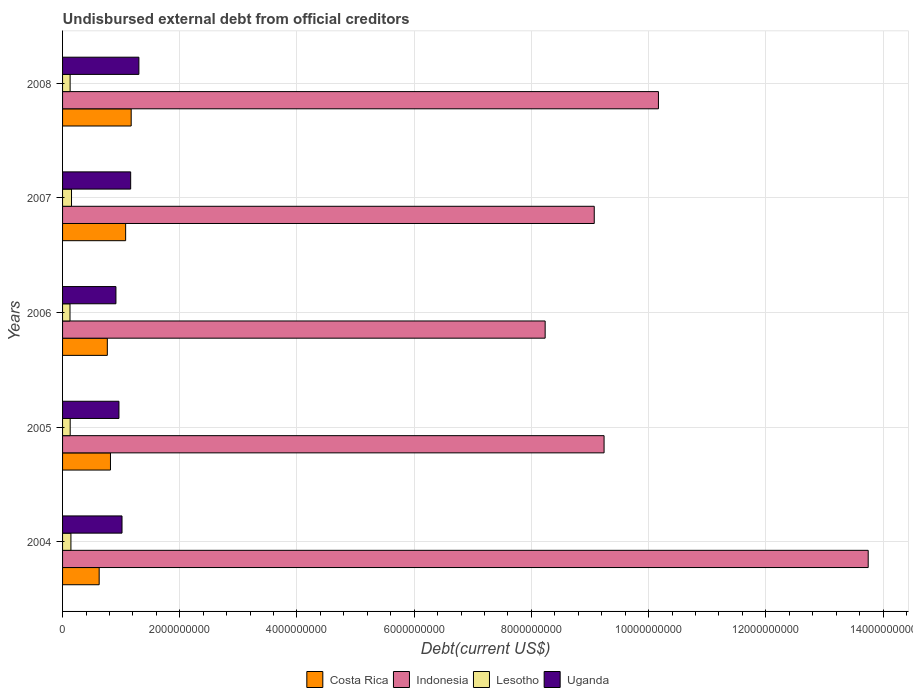How many bars are there on the 5th tick from the top?
Your answer should be very brief. 4. How many bars are there on the 4th tick from the bottom?
Offer a very short reply. 4. What is the total debt in Indonesia in 2005?
Ensure brevity in your answer.  9.24e+09. Across all years, what is the maximum total debt in Costa Rica?
Ensure brevity in your answer.  1.17e+09. Across all years, what is the minimum total debt in Lesotho?
Ensure brevity in your answer.  1.27e+08. In which year was the total debt in Costa Rica minimum?
Your answer should be compact. 2004. What is the total total debt in Uganda in the graph?
Your answer should be very brief. 5.35e+09. What is the difference between the total debt in Costa Rica in 2005 and that in 2006?
Keep it short and to the point. 5.35e+07. What is the difference between the total debt in Costa Rica in 2004 and the total debt in Indonesia in 2005?
Provide a succinct answer. -8.62e+09. What is the average total debt in Costa Rica per year?
Your answer should be very brief. 8.91e+08. In the year 2008, what is the difference between the total debt in Uganda and total debt in Indonesia?
Your answer should be very brief. -8.87e+09. What is the ratio of the total debt in Lesotho in 2004 to that in 2007?
Provide a short and direct response. 0.93. Is the total debt in Lesotho in 2007 less than that in 2008?
Provide a succinct answer. No. Is the difference between the total debt in Uganda in 2004 and 2007 greater than the difference between the total debt in Indonesia in 2004 and 2007?
Make the answer very short. No. What is the difference between the highest and the second highest total debt in Lesotho?
Your response must be concise. 1.01e+07. What is the difference between the highest and the lowest total debt in Costa Rica?
Provide a succinct answer. 5.46e+08. Is it the case that in every year, the sum of the total debt in Costa Rica and total debt in Lesotho is greater than the sum of total debt in Indonesia and total debt in Uganda?
Offer a very short reply. No. What does the 1st bar from the top in 2006 represents?
Provide a succinct answer. Uganda. What does the 2nd bar from the bottom in 2008 represents?
Your answer should be very brief. Indonesia. Are all the bars in the graph horizontal?
Your answer should be compact. Yes. Are the values on the major ticks of X-axis written in scientific E-notation?
Your answer should be very brief. No. Does the graph contain any zero values?
Give a very brief answer. No. Where does the legend appear in the graph?
Keep it short and to the point. Bottom center. How many legend labels are there?
Provide a short and direct response. 4. How are the legend labels stacked?
Give a very brief answer. Horizontal. What is the title of the graph?
Offer a very short reply. Undisbursed external debt from official creditors. Does "Eritrea" appear as one of the legend labels in the graph?
Your answer should be very brief. No. What is the label or title of the X-axis?
Keep it short and to the point. Debt(current US$). What is the label or title of the Y-axis?
Make the answer very short. Years. What is the Debt(current US$) in Costa Rica in 2004?
Your response must be concise. 6.25e+08. What is the Debt(current US$) in Indonesia in 2004?
Make the answer very short. 1.37e+1. What is the Debt(current US$) of Lesotho in 2004?
Your response must be concise. 1.43e+08. What is the Debt(current US$) of Uganda in 2004?
Ensure brevity in your answer.  1.01e+09. What is the Debt(current US$) in Costa Rica in 2005?
Provide a succinct answer. 8.17e+08. What is the Debt(current US$) in Indonesia in 2005?
Your answer should be very brief. 9.24e+09. What is the Debt(current US$) in Lesotho in 2005?
Keep it short and to the point. 1.30e+08. What is the Debt(current US$) in Uganda in 2005?
Your response must be concise. 9.62e+08. What is the Debt(current US$) of Costa Rica in 2006?
Offer a terse response. 7.64e+08. What is the Debt(current US$) of Indonesia in 2006?
Provide a short and direct response. 8.23e+09. What is the Debt(current US$) in Lesotho in 2006?
Make the answer very short. 1.27e+08. What is the Debt(current US$) of Uganda in 2006?
Provide a succinct answer. 9.11e+08. What is the Debt(current US$) in Costa Rica in 2007?
Offer a very short reply. 1.08e+09. What is the Debt(current US$) of Indonesia in 2007?
Offer a terse response. 9.07e+09. What is the Debt(current US$) of Lesotho in 2007?
Provide a short and direct response. 1.53e+08. What is the Debt(current US$) of Uganda in 2007?
Provide a short and direct response. 1.16e+09. What is the Debt(current US$) in Costa Rica in 2008?
Offer a very short reply. 1.17e+09. What is the Debt(current US$) of Indonesia in 2008?
Ensure brevity in your answer.  1.02e+1. What is the Debt(current US$) of Lesotho in 2008?
Offer a very short reply. 1.29e+08. What is the Debt(current US$) of Uganda in 2008?
Your response must be concise. 1.30e+09. Across all years, what is the maximum Debt(current US$) in Costa Rica?
Offer a terse response. 1.17e+09. Across all years, what is the maximum Debt(current US$) of Indonesia?
Offer a terse response. 1.37e+1. Across all years, what is the maximum Debt(current US$) in Lesotho?
Make the answer very short. 1.53e+08. Across all years, what is the maximum Debt(current US$) in Uganda?
Offer a very short reply. 1.30e+09. Across all years, what is the minimum Debt(current US$) in Costa Rica?
Offer a terse response. 6.25e+08. Across all years, what is the minimum Debt(current US$) in Indonesia?
Offer a terse response. 8.23e+09. Across all years, what is the minimum Debt(current US$) of Lesotho?
Your answer should be compact. 1.27e+08. Across all years, what is the minimum Debt(current US$) in Uganda?
Offer a terse response. 9.11e+08. What is the total Debt(current US$) of Costa Rica in the graph?
Make the answer very short. 4.45e+09. What is the total Debt(current US$) of Indonesia in the graph?
Provide a succinct answer. 5.05e+1. What is the total Debt(current US$) in Lesotho in the graph?
Your response must be concise. 6.81e+08. What is the total Debt(current US$) of Uganda in the graph?
Give a very brief answer. 5.35e+09. What is the difference between the Debt(current US$) of Costa Rica in 2004 and that in 2005?
Offer a very short reply. -1.93e+08. What is the difference between the Debt(current US$) in Indonesia in 2004 and that in 2005?
Your answer should be very brief. 4.51e+09. What is the difference between the Debt(current US$) in Lesotho in 2004 and that in 2005?
Your answer should be compact. 1.26e+07. What is the difference between the Debt(current US$) of Uganda in 2004 and that in 2005?
Offer a very short reply. 5.22e+07. What is the difference between the Debt(current US$) in Costa Rica in 2004 and that in 2006?
Keep it short and to the point. -1.39e+08. What is the difference between the Debt(current US$) in Indonesia in 2004 and that in 2006?
Your answer should be compact. 5.51e+09. What is the difference between the Debt(current US$) in Lesotho in 2004 and that in 2006?
Keep it short and to the point. 1.57e+07. What is the difference between the Debt(current US$) of Uganda in 2004 and that in 2006?
Provide a short and direct response. 1.04e+08. What is the difference between the Debt(current US$) of Costa Rica in 2004 and that in 2007?
Your response must be concise. -4.52e+08. What is the difference between the Debt(current US$) in Indonesia in 2004 and that in 2007?
Your response must be concise. 4.67e+09. What is the difference between the Debt(current US$) in Lesotho in 2004 and that in 2007?
Offer a terse response. -1.01e+07. What is the difference between the Debt(current US$) of Uganda in 2004 and that in 2007?
Give a very brief answer. -1.48e+08. What is the difference between the Debt(current US$) in Costa Rica in 2004 and that in 2008?
Your answer should be compact. -5.46e+08. What is the difference between the Debt(current US$) in Indonesia in 2004 and that in 2008?
Your answer should be very brief. 3.58e+09. What is the difference between the Debt(current US$) of Lesotho in 2004 and that in 2008?
Ensure brevity in your answer.  1.35e+07. What is the difference between the Debt(current US$) of Uganda in 2004 and that in 2008?
Make the answer very short. -2.88e+08. What is the difference between the Debt(current US$) in Costa Rica in 2005 and that in 2006?
Make the answer very short. 5.35e+07. What is the difference between the Debt(current US$) in Indonesia in 2005 and that in 2006?
Keep it short and to the point. 1.01e+09. What is the difference between the Debt(current US$) in Lesotho in 2005 and that in 2006?
Ensure brevity in your answer.  3.10e+06. What is the difference between the Debt(current US$) in Uganda in 2005 and that in 2006?
Make the answer very short. 5.15e+07. What is the difference between the Debt(current US$) of Costa Rica in 2005 and that in 2007?
Provide a succinct answer. -2.59e+08. What is the difference between the Debt(current US$) in Indonesia in 2005 and that in 2007?
Give a very brief answer. 1.68e+08. What is the difference between the Debt(current US$) in Lesotho in 2005 and that in 2007?
Offer a very short reply. -2.27e+07. What is the difference between the Debt(current US$) in Uganda in 2005 and that in 2007?
Keep it short and to the point. -2.00e+08. What is the difference between the Debt(current US$) of Costa Rica in 2005 and that in 2008?
Provide a succinct answer. -3.53e+08. What is the difference between the Debt(current US$) of Indonesia in 2005 and that in 2008?
Your answer should be very brief. -9.28e+08. What is the difference between the Debt(current US$) in Lesotho in 2005 and that in 2008?
Offer a very short reply. 8.88e+05. What is the difference between the Debt(current US$) of Uganda in 2005 and that in 2008?
Your response must be concise. -3.40e+08. What is the difference between the Debt(current US$) of Costa Rica in 2006 and that in 2007?
Your response must be concise. -3.12e+08. What is the difference between the Debt(current US$) of Indonesia in 2006 and that in 2007?
Provide a succinct answer. -8.38e+08. What is the difference between the Debt(current US$) in Lesotho in 2006 and that in 2007?
Offer a terse response. -2.58e+07. What is the difference between the Debt(current US$) in Uganda in 2006 and that in 2007?
Your response must be concise. -2.51e+08. What is the difference between the Debt(current US$) in Costa Rica in 2006 and that in 2008?
Your answer should be compact. -4.07e+08. What is the difference between the Debt(current US$) in Indonesia in 2006 and that in 2008?
Your answer should be compact. -1.93e+09. What is the difference between the Debt(current US$) of Lesotho in 2006 and that in 2008?
Ensure brevity in your answer.  -2.21e+06. What is the difference between the Debt(current US$) in Uganda in 2006 and that in 2008?
Offer a very short reply. -3.92e+08. What is the difference between the Debt(current US$) of Costa Rica in 2007 and that in 2008?
Your response must be concise. -9.47e+07. What is the difference between the Debt(current US$) of Indonesia in 2007 and that in 2008?
Your response must be concise. -1.10e+09. What is the difference between the Debt(current US$) in Lesotho in 2007 and that in 2008?
Your answer should be compact. 2.36e+07. What is the difference between the Debt(current US$) of Uganda in 2007 and that in 2008?
Offer a terse response. -1.40e+08. What is the difference between the Debt(current US$) of Costa Rica in 2004 and the Debt(current US$) of Indonesia in 2005?
Provide a succinct answer. -8.62e+09. What is the difference between the Debt(current US$) of Costa Rica in 2004 and the Debt(current US$) of Lesotho in 2005?
Your answer should be compact. 4.95e+08. What is the difference between the Debt(current US$) of Costa Rica in 2004 and the Debt(current US$) of Uganda in 2005?
Your response must be concise. -3.38e+08. What is the difference between the Debt(current US$) in Indonesia in 2004 and the Debt(current US$) in Lesotho in 2005?
Your response must be concise. 1.36e+1. What is the difference between the Debt(current US$) in Indonesia in 2004 and the Debt(current US$) in Uganda in 2005?
Your response must be concise. 1.28e+1. What is the difference between the Debt(current US$) of Lesotho in 2004 and the Debt(current US$) of Uganda in 2005?
Provide a succinct answer. -8.20e+08. What is the difference between the Debt(current US$) of Costa Rica in 2004 and the Debt(current US$) of Indonesia in 2006?
Offer a very short reply. -7.61e+09. What is the difference between the Debt(current US$) in Costa Rica in 2004 and the Debt(current US$) in Lesotho in 2006?
Make the answer very short. 4.98e+08. What is the difference between the Debt(current US$) in Costa Rica in 2004 and the Debt(current US$) in Uganda in 2006?
Offer a terse response. -2.86e+08. What is the difference between the Debt(current US$) in Indonesia in 2004 and the Debt(current US$) in Lesotho in 2006?
Provide a short and direct response. 1.36e+1. What is the difference between the Debt(current US$) in Indonesia in 2004 and the Debt(current US$) in Uganda in 2006?
Ensure brevity in your answer.  1.28e+1. What is the difference between the Debt(current US$) in Lesotho in 2004 and the Debt(current US$) in Uganda in 2006?
Provide a short and direct response. -7.68e+08. What is the difference between the Debt(current US$) of Costa Rica in 2004 and the Debt(current US$) of Indonesia in 2007?
Keep it short and to the point. -8.45e+09. What is the difference between the Debt(current US$) in Costa Rica in 2004 and the Debt(current US$) in Lesotho in 2007?
Your answer should be compact. 4.72e+08. What is the difference between the Debt(current US$) in Costa Rica in 2004 and the Debt(current US$) in Uganda in 2007?
Make the answer very short. -5.38e+08. What is the difference between the Debt(current US$) in Indonesia in 2004 and the Debt(current US$) in Lesotho in 2007?
Your response must be concise. 1.36e+1. What is the difference between the Debt(current US$) of Indonesia in 2004 and the Debt(current US$) of Uganda in 2007?
Provide a short and direct response. 1.26e+1. What is the difference between the Debt(current US$) of Lesotho in 2004 and the Debt(current US$) of Uganda in 2007?
Offer a very short reply. -1.02e+09. What is the difference between the Debt(current US$) in Costa Rica in 2004 and the Debt(current US$) in Indonesia in 2008?
Your answer should be compact. -9.54e+09. What is the difference between the Debt(current US$) in Costa Rica in 2004 and the Debt(current US$) in Lesotho in 2008?
Your answer should be compact. 4.95e+08. What is the difference between the Debt(current US$) of Costa Rica in 2004 and the Debt(current US$) of Uganda in 2008?
Provide a short and direct response. -6.78e+08. What is the difference between the Debt(current US$) of Indonesia in 2004 and the Debt(current US$) of Lesotho in 2008?
Your answer should be very brief. 1.36e+1. What is the difference between the Debt(current US$) of Indonesia in 2004 and the Debt(current US$) of Uganda in 2008?
Offer a terse response. 1.24e+1. What is the difference between the Debt(current US$) of Lesotho in 2004 and the Debt(current US$) of Uganda in 2008?
Provide a short and direct response. -1.16e+09. What is the difference between the Debt(current US$) in Costa Rica in 2005 and the Debt(current US$) in Indonesia in 2006?
Your response must be concise. -7.42e+09. What is the difference between the Debt(current US$) in Costa Rica in 2005 and the Debt(current US$) in Lesotho in 2006?
Your answer should be compact. 6.90e+08. What is the difference between the Debt(current US$) of Costa Rica in 2005 and the Debt(current US$) of Uganda in 2006?
Ensure brevity in your answer.  -9.34e+07. What is the difference between the Debt(current US$) of Indonesia in 2005 and the Debt(current US$) of Lesotho in 2006?
Offer a very short reply. 9.11e+09. What is the difference between the Debt(current US$) in Indonesia in 2005 and the Debt(current US$) in Uganda in 2006?
Your answer should be very brief. 8.33e+09. What is the difference between the Debt(current US$) in Lesotho in 2005 and the Debt(current US$) in Uganda in 2006?
Offer a terse response. -7.81e+08. What is the difference between the Debt(current US$) of Costa Rica in 2005 and the Debt(current US$) of Indonesia in 2007?
Your answer should be compact. -8.25e+09. What is the difference between the Debt(current US$) of Costa Rica in 2005 and the Debt(current US$) of Lesotho in 2007?
Provide a short and direct response. 6.65e+08. What is the difference between the Debt(current US$) of Costa Rica in 2005 and the Debt(current US$) of Uganda in 2007?
Provide a succinct answer. -3.45e+08. What is the difference between the Debt(current US$) in Indonesia in 2005 and the Debt(current US$) in Lesotho in 2007?
Your answer should be compact. 9.09e+09. What is the difference between the Debt(current US$) of Indonesia in 2005 and the Debt(current US$) of Uganda in 2007?
Make the answer very short. 8.08e+09. What is the difference between the Debt(current US$) of Lesotho in 2005 and the Debt(current US$) of Uganda in 2007?
Your response must be concise. -1.03e+09. What is the difference between the Debt(current US$) in Costa Rica in 2005 and the Debt(current US$) in Indonesia in 2008?
Your answer should be very brief. -9.35e+09. What is the difference between the Debt(current US$) of Costa Rica in 2005 and the Debt(current US$) of Lesotho in 2008?
Provide a succinct answer. 6.88e+08. What is the difference between the Debt(current US$) of Costa Rica in 2005 and the Debt(current US$) of Uganda in 2008?
Make the answer very short. -4.85e+08. What is the difference between the Debt(current US$) of Indonesia in 2005 and the Debt(current US$) of Lesotho in 2008?
Ensure brevity in your answer.  9.11e+09. What is the difference between the Debt(current US$) of Indonesia in 2005 and the Debt(current US$) of Uganda in 2008?
Your answer should be very brief. 7.94e+09. What is the difference between the Debt(current US$) in Lesotho in 2005 and the Debt(current US$) in Uganda in 2008?
Offer a very short reply. -1.17e+09. What is the difference between the Debt(current US$) of Costa Rica in 2006 and the Debt(current US$) of Indonesia in 2007?
Offer a terse response. -8.31e+09. What is the difference between the Debt(current US$) of Costa Rica in 2006 and the Debt(current US$) of Lesotho in 2007?
Offer a very short reply. 6.11e+08. What is the difference between the Debt(current US$) of Costa Rica in 2006 and the Debt(current US$) of Uganda in 2007?
Offer a very short reply. -3.98e+08. What is the difference between the Debt(current US$) of Indonesia in 2006 and the Debt(current US$) of Lesotho in 2007?
Your response must be concise. 8.08e+09. What is the difference between the Debt(current US$) of Indonesia in 2006 and the Debt(current US$) of Uganda in 2007?
Your response must be concise. 7.07e+09. What is the difference between the Debt(current US$) of Lesotho in 2006 and the Debt(current US$) of Uganda in 2007?
Your answer should be compact. -1.04e+09. What is the difference between the Debt(current US$) of Costa Rica in 2006 and the Debt(current US$) of Indonesia in 2008?
Provide a succinct answer. -9.40e+09. What is the difference between the Debt(current US$) in Costa Rica in 2006 and the Debt(current US$) in Lesotho in 2008?
Give a very brief answer. 6.35e+08. What is the difference between the Debt(current US$) in Costa Rica in 2006 and the Debt(current US$) in Uganda in 2008?
Provide a succinct answer. -5.38e+08. What is the difference between the Debt(current US$) of Indonesia in 2006 and the Debt(current US$) of Lesotho in 2008?
Your response must be concise. 8.11e+09. What is the difference between the Debt(current US$) of Indonesia in 2006 and the Debt(current US$) of Uganda in 2008?
Give a very brief answer. 6.93e+09. What is the difference between the Debt(current US$) in Lesotho in 2006 and the Debt(current US$) in Uganda in 2008?
Provide a short and direct response. -1.18e+09. What is the difference between the Debt(current US$) in Costa Rica in 2007 and the Debt(current US$) in Indonesia in 2008?
Your answer should be compact. -9.09e+09. What is the difference between the Debt(current US$) of Costa Rica in 2007 and the Debt(current US$) of Lesotho in 2008?
Provide a succinct answer. 9.47e+08. What is the difference between the Debt(current US$) in Costa Rica in 2007 and the Debt(current US$) in Uganda in 2008?
Provide a short and direct response. -2.26e+08. What is the difference between the Debt(current US$) in Indonesia in 2007 and the Debt(current US$) in Lesotho in 2008?
Your answer should be compact. 8.94e+09. What is the difference between the Debt(current US$) of Indonesia in 2007 and the Debt(current US$) of Uganda in 2008?
Give a very brief answer. 7.77e+09. What is the difference between the Debt(current US$) in Lesotho in 2007 and the Debt(current US$) in Uganda in 2008?
Your answer should be compact. -1.15e+09. What is the average Debt(current US$) in Costa Rica per year?
Provide a succinct answer. 8.91e+08. What is the average Debt(current US$) in Indonesia per year?
Offer a terse response. 1.01e+1. What is the average Debt(current US$) of Lesotho per year?
Offer a very short reply. 1.36e+08. What is the average Debt(current US$) of Uganda per year?
Make the answer very short. 1.07e+09. In the year 2004, what is the difference between the Debt(current US$) in Costa Rica and Debt(current US$) in Indonesia?
Provide a succinct answer. -1.31e+1. In the year 2004, what is the difference between the Debt(current US$) of Costa Rica and Debt(current US$) of Lesotho?
Offer a terse response. 4.82e+08. In the year 2004, what is the difference between the Debt(current US$) in Costa Rica and Debt(current US$) in Uganda?
Provide a short and direct response. -3.90e+08. In the year 2004, what is the difference between the Debt(current US$) of Indonesia and Debt(current US$) of Lesotho?
Offer a terse response. 1.36e+1. In the year 2004, what is the difference between the Debt(current US$) of Indonesia and Debt(current US$) of Uganda?
Keep it short and to the point. 1.27e+1. In the year 2004, what is the difference between the Debt(current US$) of Lesotho and Debt(current US$) of Uganda?
Make the answer very short. -8.72e+08. In the year 2005, what is the difference between the Debt(current US$) of Costa Rica and Debt(current US$) of Indonesia?
Make the answer very short. -8.42e+09. In the year 2005, what is the difference between the Debt(current US$) of Costa Rica and Debt(current US$) of Lesotho?
Offer a terse response. 6.87e+08. In the year 2005, what is the difference between the Debt(current US$) in Costa Rica and Debt(current US$) in Uganda?
Give a very brief answer. -1.45e+08. In the year 2005, what is the difference between the Debt(current US$) in Indonesia and Debt(current US$) in Lesotho?
Your answer should be very brief. 9.11e+09. In the year 2005, what is the difference between the Debt(current US$) in Indonesia and Debt(current US$) in Uganda?
Your answer should be very brief. 8.28e+09. In the year 2005, what is the difference between the Debt(current US$) in Lesotho and Debt(current US$) in Uganda?
Give a very brief answer. -8.32e+08. In the year 2006, what is the difference between the Debt(current US$) of Costa Rica and Debt(current US$) of Indonesia?
Your answer should be very brief. -7.47e+09. In the year 2006, what is the difference between the Debt(current US$) in Costa Rica and Debt(current US$) in Lesotho?
Your response must be concise. 6.37e+08. In the year 2006, what is the difference between the Debt(current US$) in Costa Rica and Debt(current US$) in Uganda?
Offer a terse response. -1.47e+08. In the year 2006, what is the difference between the Debt(current US$) in Indonesia and Debt(current US$) in Lesotho?
Provide a short and direct response. 8.11e+09. In the year 2006, what is the difference between the Debt(current US$) of Indonesia and Debt(current US$) of Uganda?
Your answer should be very brief. 7.32e+09. In the year 2006, what is the difference between the Debt(current US$) of Lesotho and Debt(current US$) of Uganda?
Offer a very short reply. -7.84e+08. In the year 2007, what is the difference between the Debt(current US$) in Costa Rica and Debt(current US$) in Indonesia?
Ensure brevity in your answer.  -8.00e+09. In the year 2007, what is the difference between the Debt(current US$) of Costa Rica and Debt(current US$) of Lesotho?
Make the answer very short. 9.23e+08. In the year 2007, what is the difference between the Debt(current US$) of Costa Rica and Debt(current US$) of Uganda?
Your answer should be compact. -8.60e+07. In the year 2007, what is the difference between the Debt(current US$) of Indonesia and Debt(current US$) of Lesotho?
Offer a very short reply. 8.92e+09. In the year 2007, what is the difference between the Debt(current US$) of Indonesia and Debt(current US$) of Uganda?
Offer a terse response. 7.91e+09. In the year 2007, what is the difference between the Debt(current US$) of Lesotho and Debt(current US$) of Uganda?
Offer a very short reply. -1.01e+09. In the year 2008, what is the difference between the Debt(current US$) in Costa Rica and Debt(current US$) in Indonesia?
Your response must be concise. -9.00e+09. In the year 2008, what is the difference between the Debt(current US$) of Costa Rica and Debt(current US$) of Lesotho?
Ensure brevity in your answer.  1.04e+09. In the year 2008, what is the difference between the Debt(current US$) of Costa Rica and Debt(current US$) of Uganda?
Provide a short and direct response. -1.31e+08. In the year 2008, what is the difference between the Debt(current US$) of Indonesia and Debt(current US$) of Lesotho?
Offer a very short reply. 1.00e+1. In the year 2008, what is the difference between the Debt(current US$) of Indonesia and Debt(current US$) of Uganda?
Make the answer very short. 8.87e+09. In the year 2008, what is the difference between the Debt(current US$) in Lesotho and Debt(current US$) in Uganda?
Your answer should be compact. -1.17e+09. What is the ratio of the Debt(current US$) of Costa Rica in 2004 to that in 2005?
Offer a very short reply. 0.76. What is the ratio of the Debt(current US$) of Indonesia in 2004 to that in 2005?
Offer a very short reply. 1.49. What is the ratio of the Debt(current US$) in Lesotho in 2004 to that in 2005?
Provide a short and direct response. 1.1. What is the ratio of the Debt(current US$) in Uganda in 2004 to that in 2005?
Your answer should be compact. 1.05. What is the ratio of the Debt(current US$) in Costa Rica in 2004 to that in 2006?
Give a very brief answer. 0.82. What is the ratio of the Debt(current US$) in Indonesia in 2004 to that in 2006?
Ensure brevity in your answer.  1.67. What is the ratio of the Debt(current US$) in Lesotho in 2004 to that in 2006?
Make the answer very short. 1.12. What is the ratio of the Debt(current US$) of Uganda in 2004 to that in 2006?
Provide a succinct answer. 1.11. What is the ratio of the Debt(current US$) of Costa Rica in 2004 to that in 2007?
Give a very brief answer. 0.58. What is the ratio of the Debt(current US$) of Indonesia in 2004 to that in 2007?
Your answer should be compact. 1.52. What is the ratio of the Debt(current US$) in Lesotho in 2004 to that in 2007?
Your response must be concise. 0.93. What is the ratio of the Debt(current US$) in Uganda in 2004 to that in 2007?
Make the answer very short. 0.87. What is the ratio of the Debt(current US$) in Costa Rica in 2004 to that in 2008?
Give a very brief answer. 0.53. What is the ratio of the Debt(current US$) in Indonesia in 2004 to that in 2008?
Keep it short and to the point. 1.35. What is the ratio of the Debt(current US$) in Lesotho in 2004 to that in 2008?
Keep it short and to the point. 1.1. What is the ratio of the Debt(current US$) of Uganda in 2004 to that in 2008?
Offer a very short reply. 0.78. What is the ratio of the Debt(current US$) in Costa Rica in 2005 to that in 2006?
Provide a short and direct response. 1.07. What is the ratio of the Debt(current US$) in Indonesia in 2005 to that in 2006?
Give a very brief answer. 1.12. What is the ratio of the Debt(current US$) in Lesotho in 2005 to that in 2006?
Make the answer very short. 1.02. What is the ratio of the Debt(current US$) in Uganda in 2005 to that in 2006?
Keep it short and to the point. 1.06. What is the ratio of the Debt(current US$) in Costa Rica in 2005 to that in 2007?
Provide a short and direct response. 0.76. What is the ratio of the Debt(current US$) of Indonesia in 2005 to that in 2007?
Your answer should be compact. 1.02. What is the ratio of the Debt(current US$) of Lesotho in 2005 to that in 2007?
Keep it short and to the point. 0.85. What is the ratio of the Debt(current US$) in Uganda in 2005 to that in 2007?
Offer a very short reply. 0.83. What is the ratio of the Debt(current US$) of Costa Rica in 2005 to that in 2008?
Provide a succinct answer. 0.7. What is the ratio of the Debt(current US$) of Indonesia in 2005 to that in 2008?
Ensure brevity in your answer.  0.91. What is the ratio of the Debt(current US$) in Uganda in 2005 to that in 2008?
Offer a very short reply. 0.74. What is the ratio of the Debt(current US$) of Costa Rica in 2006 to that in 2007?
Ensure brevity in your answer.  0.71. What is the ratio of the Debt(current US$) in Indonesia in 2006 to that in 2007?
Give a very brief answer. 0.91. What is the ratio of the Debt(current US$) of Lesotho in 2006 to that in 2007?
Your answer should be very brief. 0.83. What is the ratio of the Debt(current US$) of Uganda in 2006 to that in 2007?
Your answer should be compact. 0.78. What is the ratio of the Debt(current US$) in Costa Rica in 2006 to that in 2008?
Give a very brief answer. 0.65. What is the ratio of the Debt(current US$) in Indonesia in 2006 to that in 2008?
Offer a terse response. 0.81. What is the ratio of the Debt(current US$) in Lesotho in 2006 to that in 2008?
Give a very brief answer. 0.98. What is the ratio of the Debt(current US$) of Uganda in 2006 to that in 2008?
Make the answer very short. 0.7. What is the ratio of the Debt(current US$) in Costa Rica in 2007 to that in 2008?
Offer a very short reply. 0.92. What is the ratio of the Debt(current US$) in Indonesia in 2007 to that in 2008?
Provide a short and direct response. 0.89. What is the ratio of the Debt(current US$) in Lesotho in 2007 to that in 2008?
Give a very brief answer. 1.18. What is the ratio of the Debt(current US$) of Uganda in 2007 to that in 2008?
Give a very brief answer. 0.89. What is the difference between the highest and the second highest Debt(current US$) of Costa Rica?
Your response must be concise. 9.47e+07. What is the difference between the highest and the second highest Debt(current US$) of Indonesia?
Your answer should be compact. 3.58e+09. What is the difference between the highest and the second highest Debt(current US$) of Lesotho?
Provide a succinct answer. 1.01e+07. What is the difference between the highest and the second highest Debt(current US$) in Uganda?
Give a very brief answer. 1.40e+08. What is the difference between the highest and the lowest Debt(current US$) in Costa Rica?
Ensure brevity in your answer.  5.46e+08. What is the difference between the highest and the lowest Debt(current US$) of Indonesia?
Give a very brief answer. 5.51e+09. What is the difference between the highest and the lowest Debt(current US$) in Lesotho?
Offer a terse response. 2.58e+07. What is the difference between the highest and the lowest Debt(current US$) of Uganda?
Give a very brief answer. 3.92e+08. 